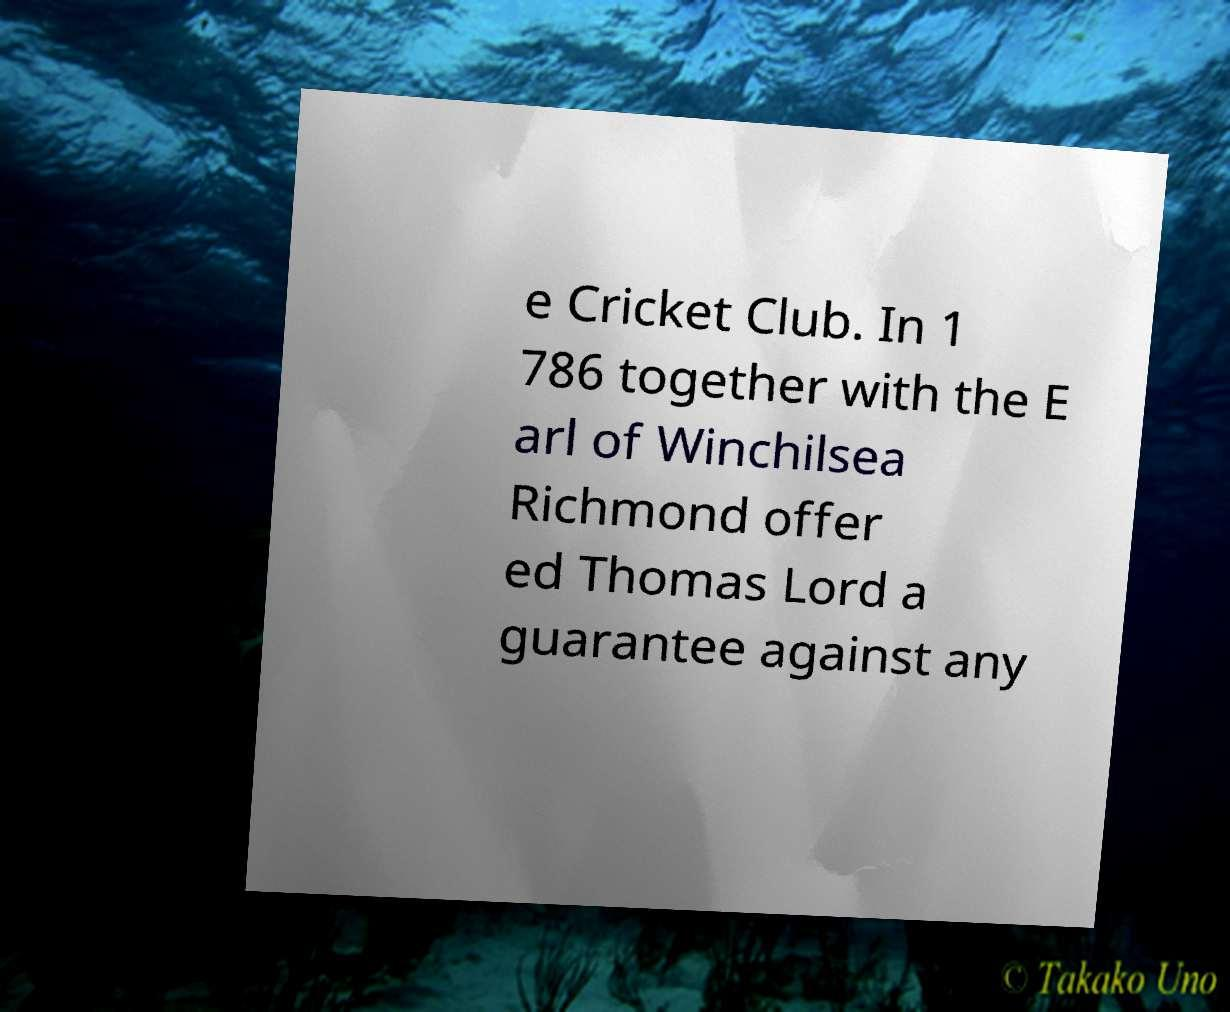There's text embedded in this image that I need extracted. Can you transcribe it verbatim? e Cricket Club. In 1 786 together with the E arl of Winchilsea Richmond offer ed Thomas Lord a guarantee against any 